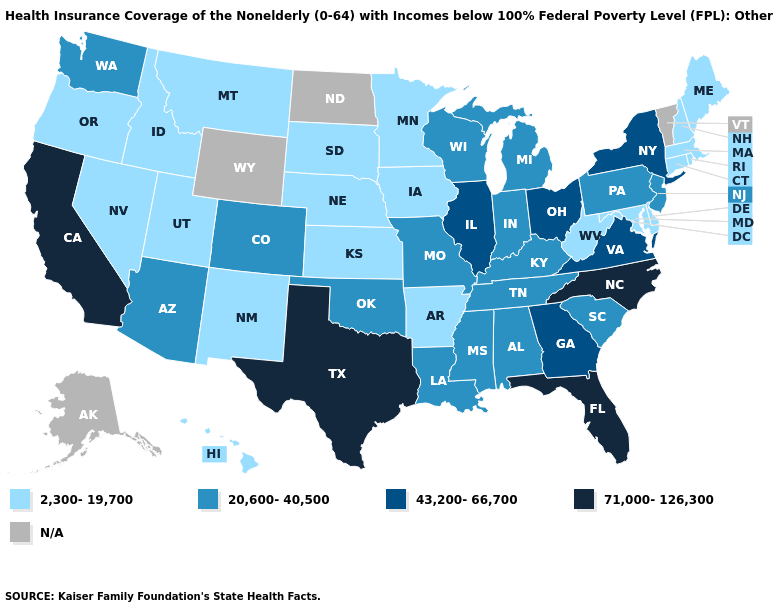Does California have the highest value in the USA?
Short answer required. Yes. What is the value of New Mexico?
Answer briefly. 2,300-19,700. Name the states that have a value in the range 43,200-66,700?
Keep it brief. Georgia, Illinois, New York, Ohio, Virginia. Among the states that border Virginia , which have the lowest value?
Keep it brief. Maryland, West Virginia. Name the states that have a value in the range 71,000-126,300?
Quick response, please. California, Florida, North Carolina, Texas. Name the states that have a value in the range 71,000-126,300?
Write a very short answer. California, Florida, North Carolina, Texas. What is the lowest value in the USA?
Keep it brief. 2,300-19,700. Which states hav the highest value in the South?
Be succinct. Florida, North Carolina, Texas. Among the states that border Wyoming , does Nebraska have the lowest value?
Answer briefly. Yes. Name the states that have a value in the range 71,000-126,300?
Concise answer only. California, Florida, North Carolina, Texas. Among the states that border Virginia , does Kentucky have the highest value?
Write a very short answer. No. 